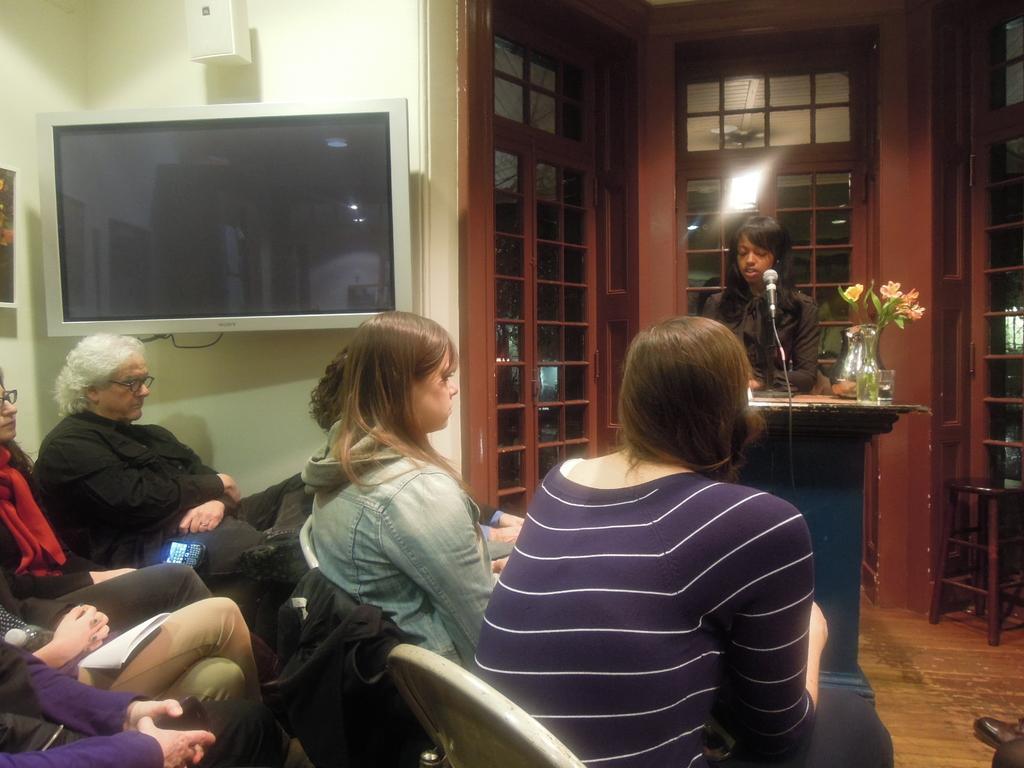Could you give a brief overview of what you see in this image? In this picture woman sitting on the chair and onto their left television and in front of them there is a girl talking into microphone 